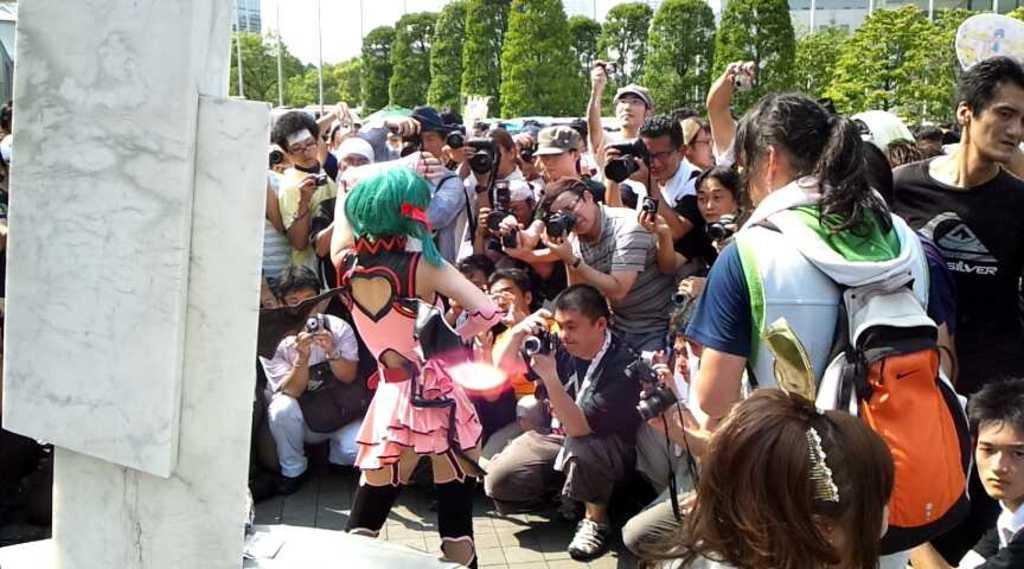Please provide a concise description of this image. In this image I can see number of people and in the front I can see one of them is carrying a bag. I can also see most of them are holding cameras and few of them are wearing caps. In the background I can see number of trees, number of poles and few buildings. 